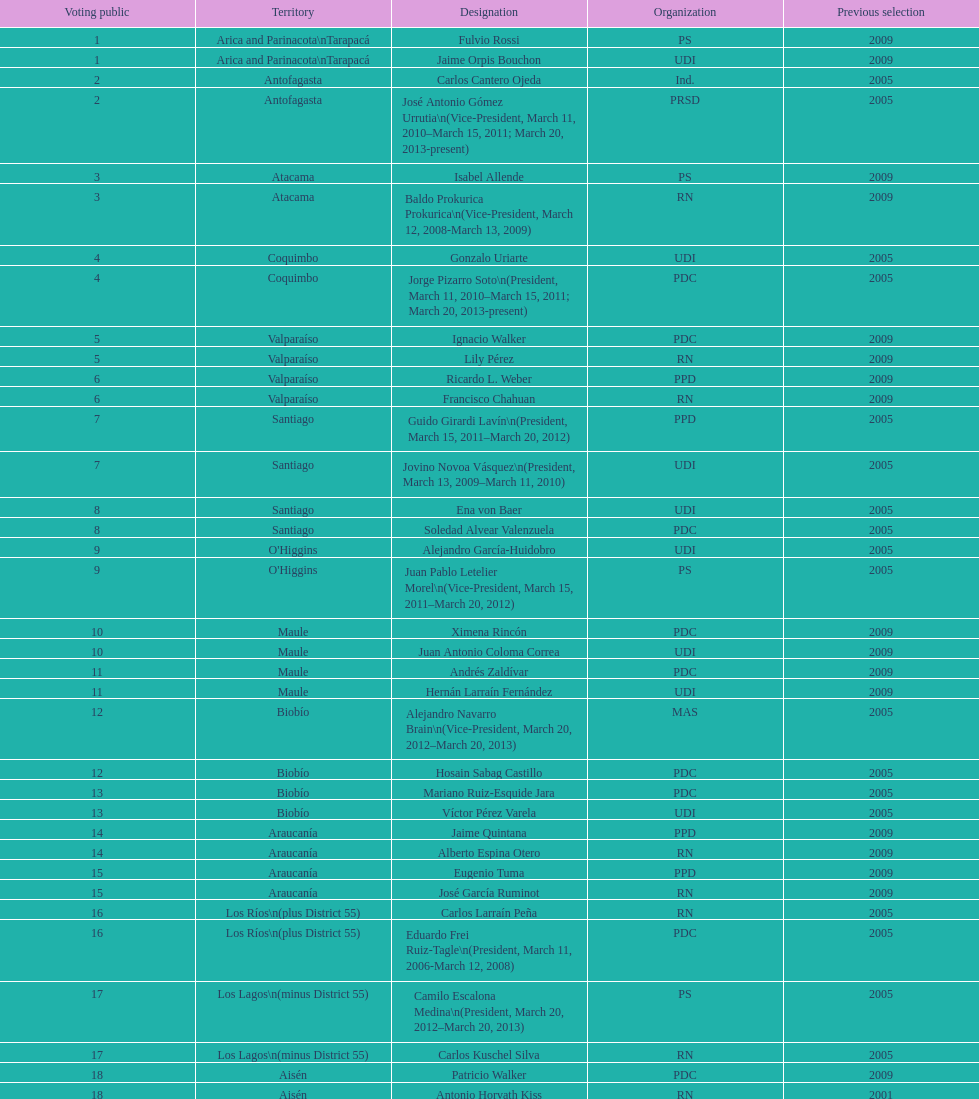What is the first name on the table? Fulvio Rossi. 